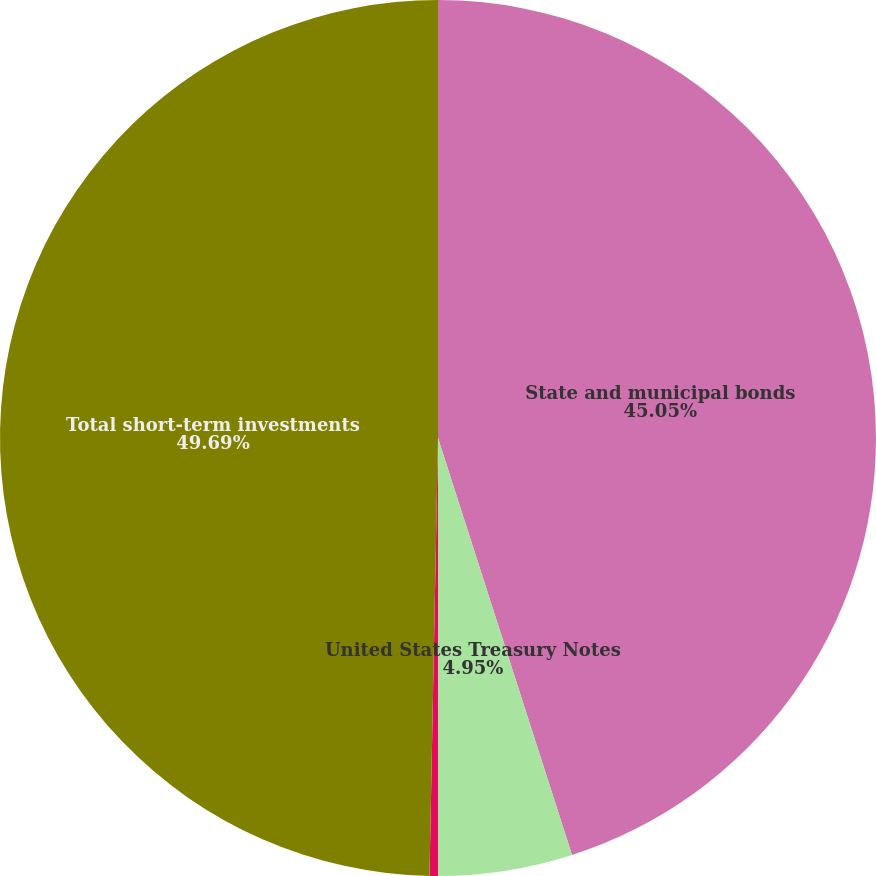Convert chart. <chart><loc_0><loc_0><loc_500><loc_500><pie_chart><fcel>State and municipal bonds<fcel>United States Treasury Notes<fcel>Corporate Bonds<fcel>Total short-term investments<nl><fcel>45.05%<fcel>4.95%<fcel>0.31%<fcel>49.69%<nl></chart> 